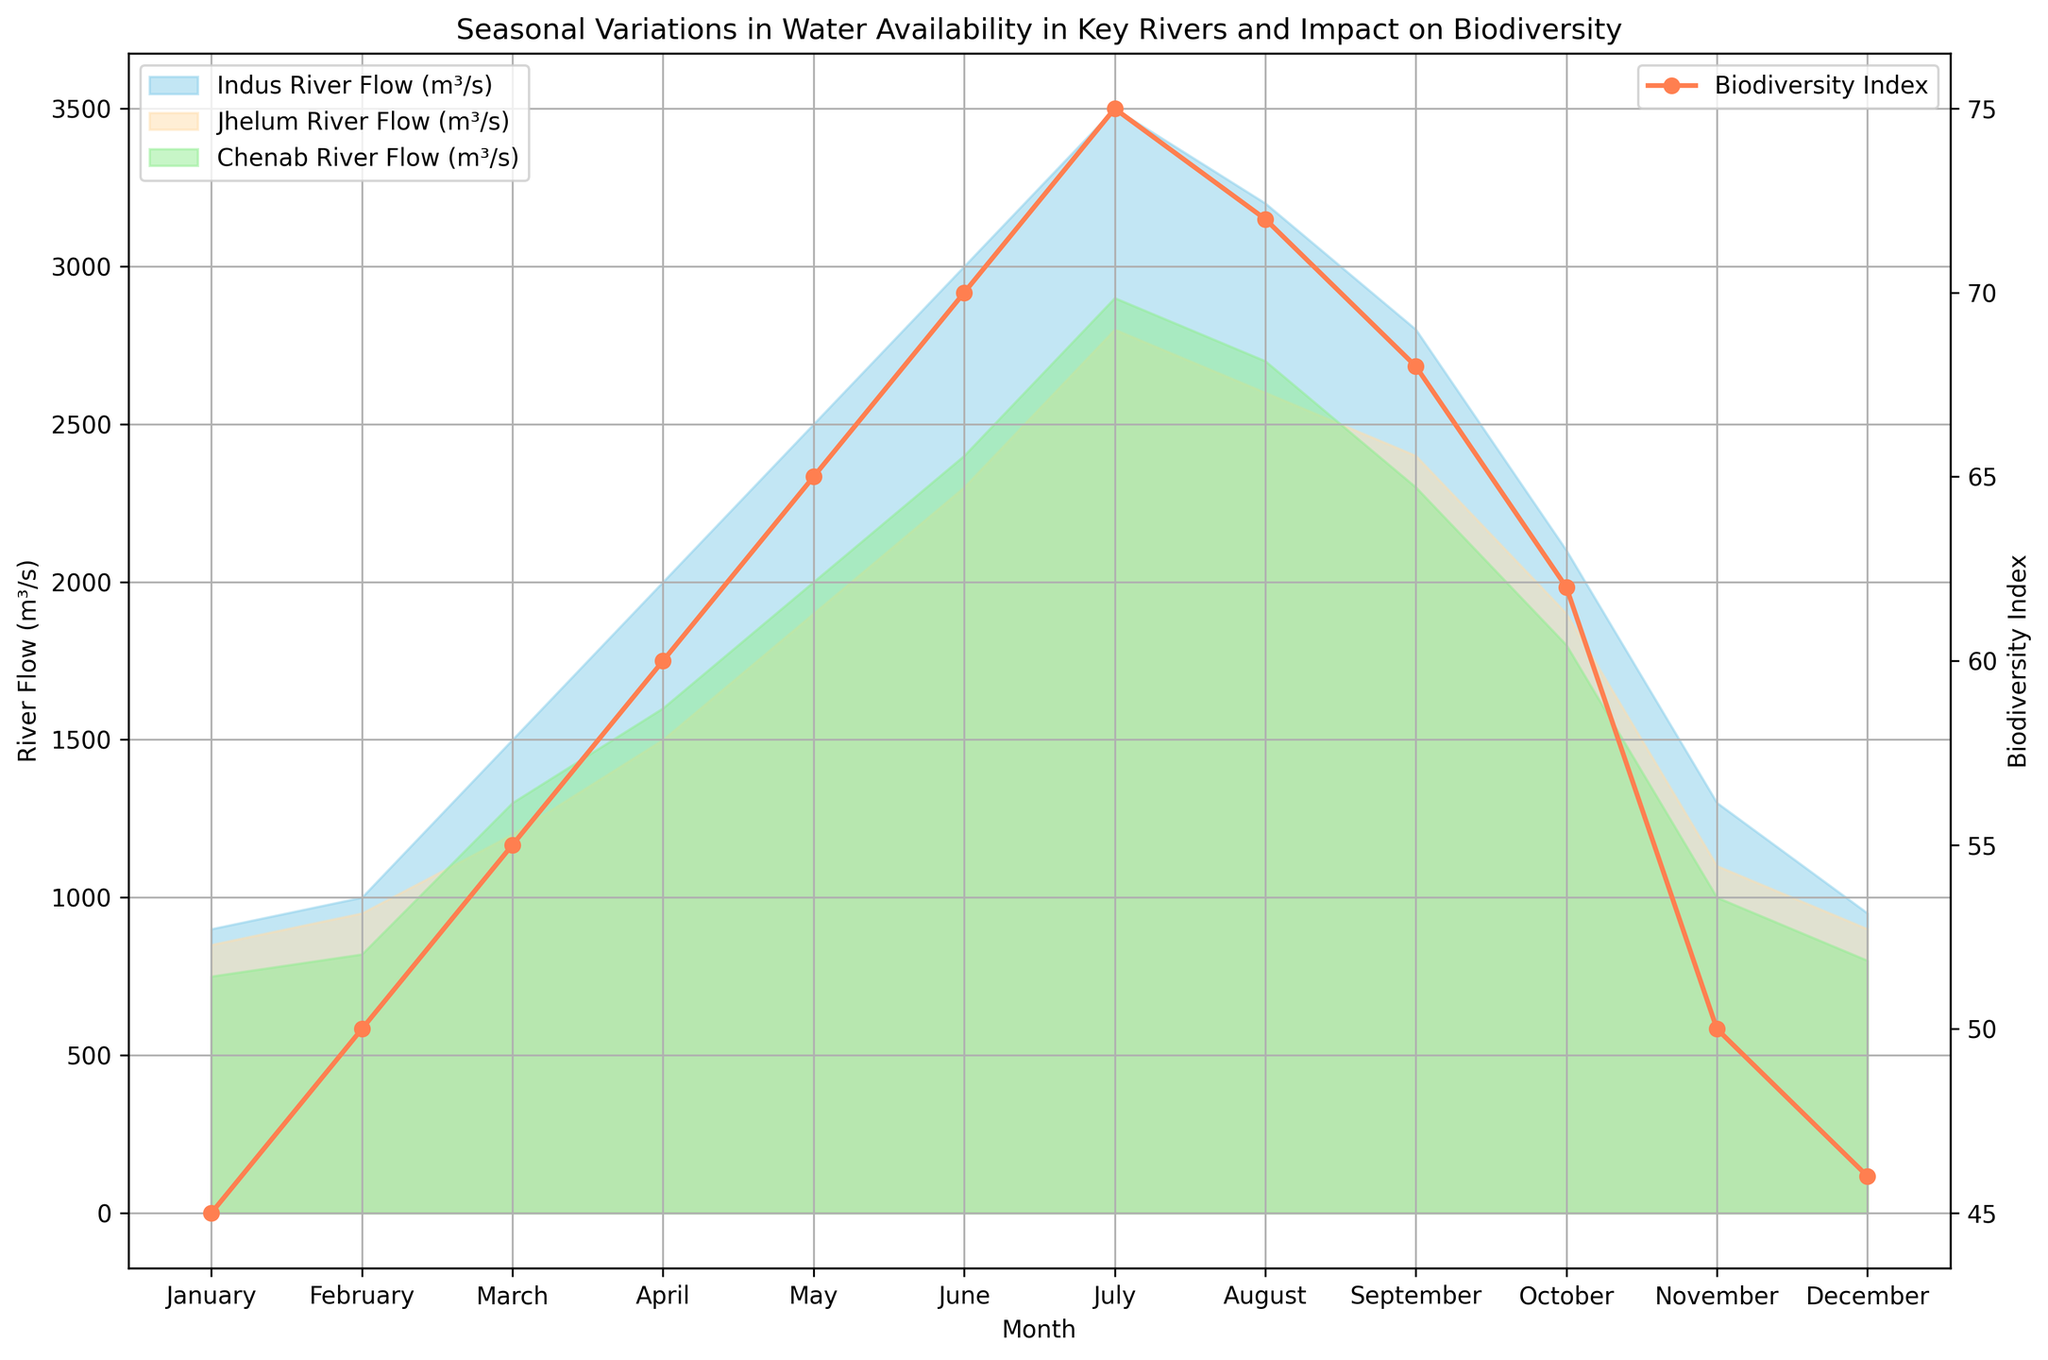What is the difference in the Indus River Flow between January and July? The Indus River Flow in January is 900 m³/s, and in July it is 3500 m³/s. The difference is 3500 - 900 = 2600 m³/s.
Answer: 2600 m³/s Which month shows the highest Biodiversity Index, and what is the value? The Biodiversity Index is highest in July, with a value of 75.
Answer: July, 75 What is the average flow of the Chenab River from April to June inclusive? The Chenab River flows are 1600 (April), 2000 (May), and 2400 (June). Their average is (1600 + 2000 + 2400) / 3 = 6000 / 3 = 2000 m³/s.
Answer: 2000 m³/s How does the Jhelum River Flow compare between March and October? The Jhelum River Flow in March is 1200 m³/s, and in October it is 1900 m³/s. The flow in October is higher by 1900 - 1200 = 700 m³/s.
Answer: Higher by 700 m³/s In which month is the difference between the Indus River Flow and Biodiversity Index the greatest? Subtract the Biodiversity Index from the Indus River Flow for each month:
  January: 900 - 45 = 855
  February: 1000 - 50 = 950
  March: 1500 - 55 = 1445
  April: 2000 - 60 = 1940
  May: 2500 - 65 = 2435
  June: 3000 - 70 = 2930
  July: 3500 - 75 = 3425
  August: 3200 - 72 = 3128
  September: 2800 - 68 = 2732
  October: 2100 - 62 = 2038
  November: 1300 - 50 = 1250
  December: 950 - 46 = 904
  The greatest difference is in July, with a value of 3425.
Answer: July What is the overall trend in Biodiversity Index as the water flows increase from January to July? As the water flows of all three rivers increase from January to July, the Biodiversity Index also increases steadily from 45 to 75.
Answer: Increases Which river shows the smallest variation in flow throughout the year? The flows are as follows:
  - Indus: 900 (January) to 3500 (July), variation of 3500 - 900 = 2600 m³/s
  - Jhelum: 850 (January) to 2800 (July), variation of 2800 - 850 = 1950 m³/s
  - Chenab: 750 (January) to 2900 (July), variation of 2900 - 750 = 2150 m³/s
  The Jhelum River has the smallest variation with 1950 m³/s.
Answer: Jhelum River During which month does the Biodiversity Index start to decrease, and what is the initial value before decreasing? The Biodiversity Index starts to decrease in August with a value of 75 in July before the decrease.
Answer: August, 75 What is the sum of the Biodiversity Index values from January to March? The Biodiversity Index values are 45 (January), 50 (February), and 55 (March). The sum is 45 + 50 + 55 = 150.
Answer: 150 In which month does the Indus River Flow surpass 2000 m³/s for the first time? The Indus River Flow surpasses 2000 m³/s for the first time in April with a flow of 2000 m³/s.
Answer: April 